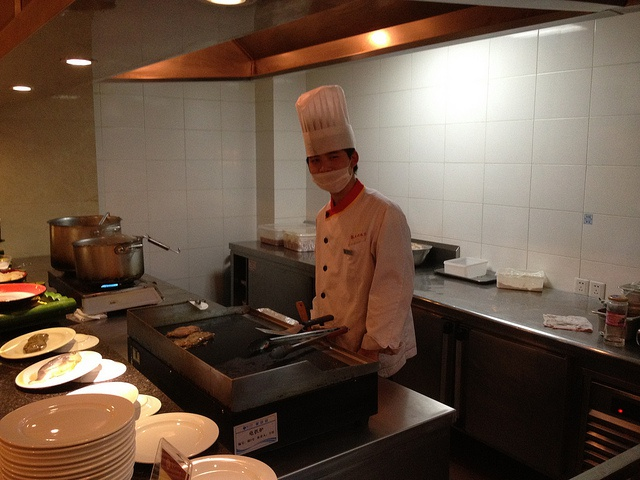Describe the objects in this image and their specific colors. I can see people in maroon and brown tones, oven in maroon, black, and gray tones, bottle in maroon, black, and gray tones, and bowl in maroon, darkgray, and gray tones in this image. 